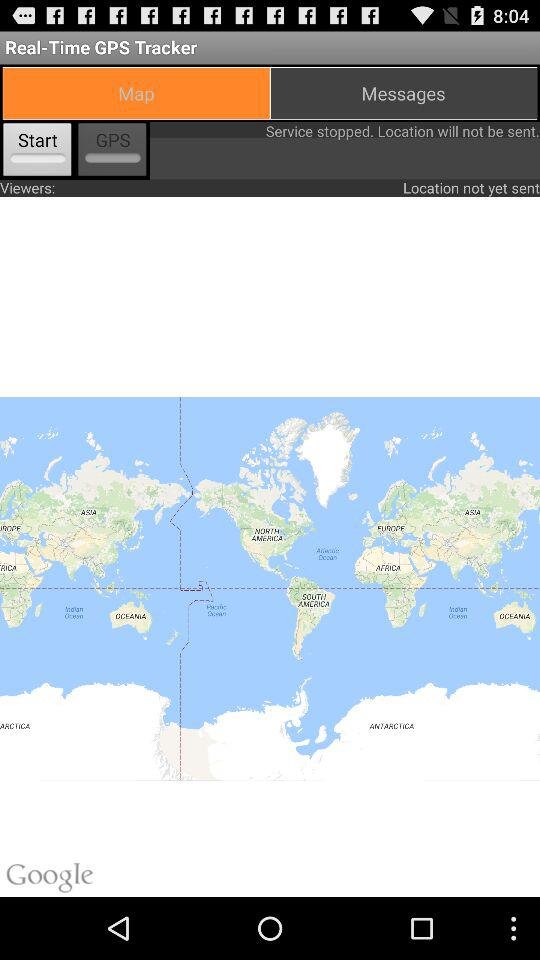How many viewers are there?
Answer the question using a single word or phrase. 0 